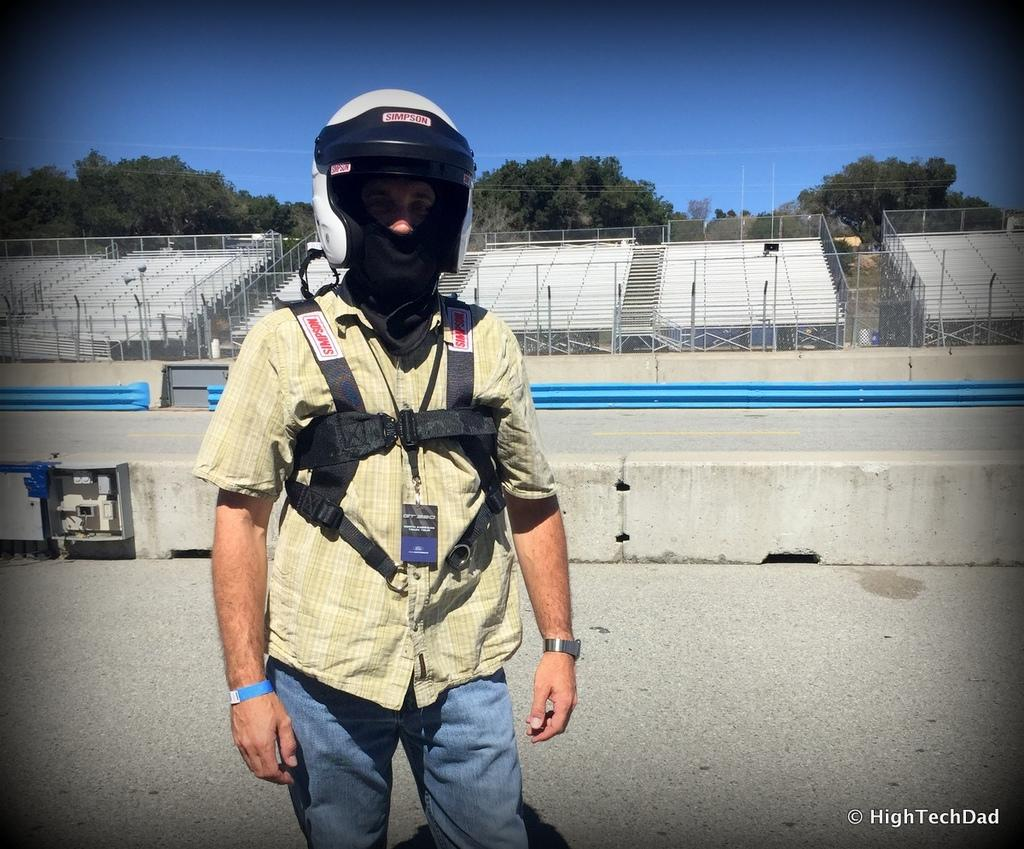What is the man in the image doing? The man is standing on the land in the image. What is the man wearing on his head? The man is wearing a white helmet on his head. What can be seen in the background of the image? There are trees and the sky visible in the background of the image. What type of apple is the man holding in the image? There is no apple present in the image; the man is wearing a white helmet on his head. 